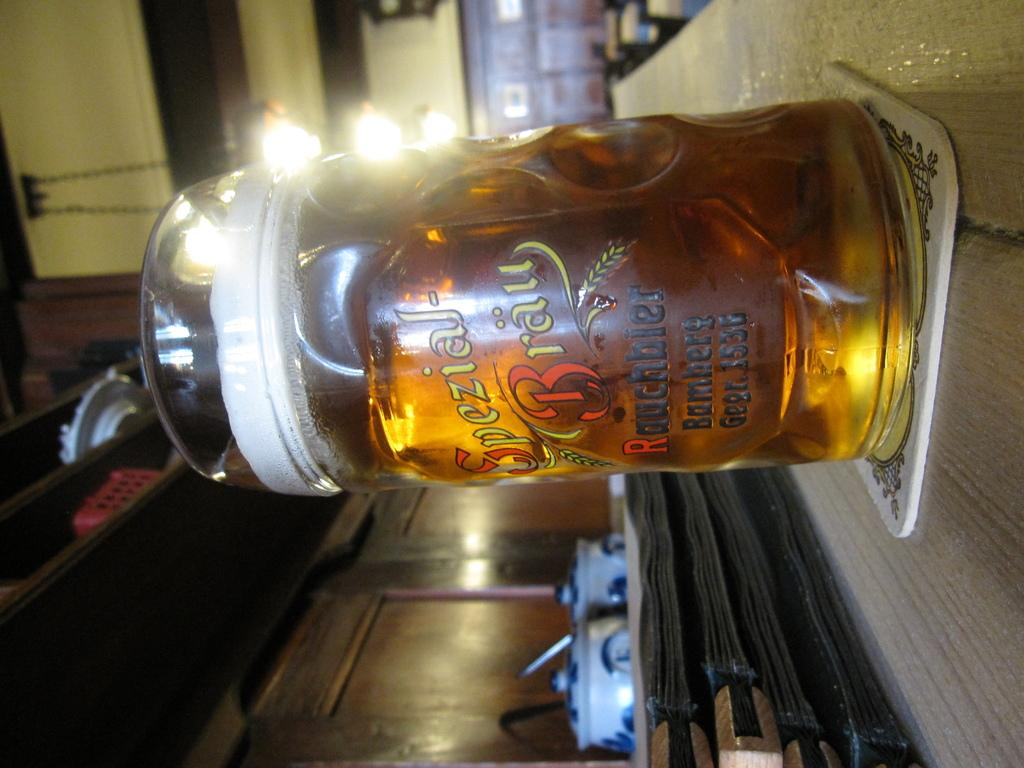<image>
Create a compact narrative representing the image presented. a bottle of Spezial Brau that is sideways 